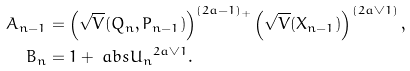Convert formula to latex. <formula><loc_0><loc_0><loc_500><loc_500>A _ { n - 1 } & = \left ( \sqrt { V } ( Q _ { n } , P _ { n - 1 } ) \right ) ^ { ( 2 a - 1 ) _ { + } } \left ( \sqrt { V } ( X _ { n - 1 } ) \right ) ^ { ( 2 a \vee 1 ) } , \\ B _ { n } & = 1 + \ a b s { U _ { n } } ^ { 2 a \vee 1 } .</formula> 